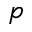<formula> <loc_0><loc_0><loc_500><loc_500>p</formula> 